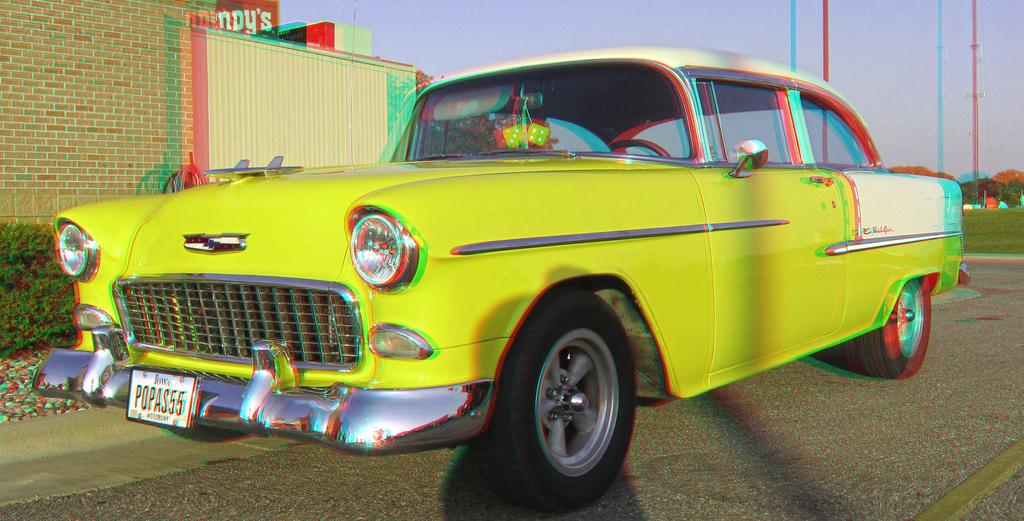Provide a one-sentence caption for the provided image. A yellow colored vintage automobile that is registered in Iowa. 